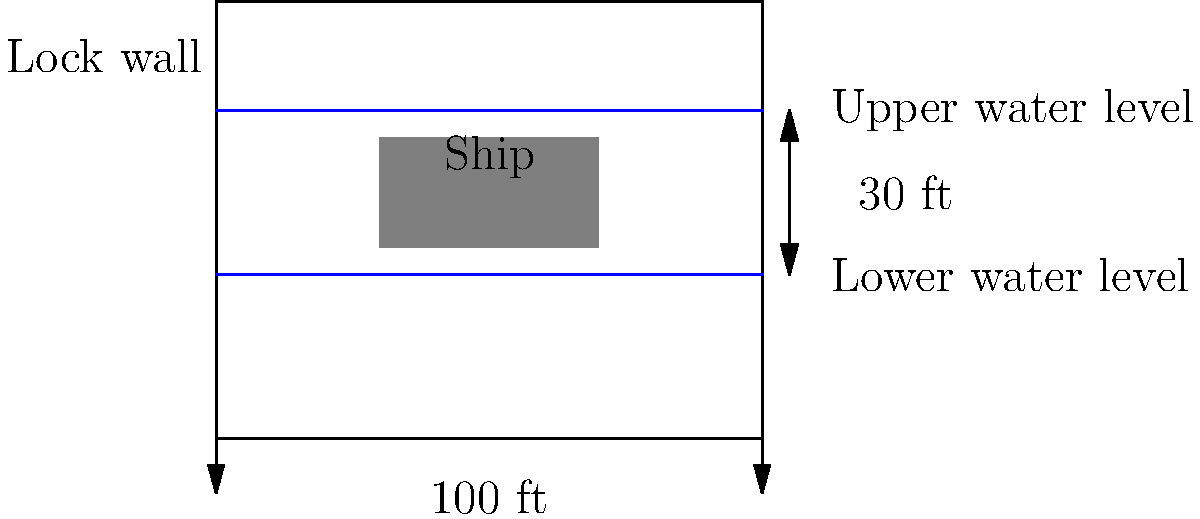In the cross-sectional design of the Panama Canal locks, what is the typical difference in water levels between the upper and lower chambers, and how does this affect the positioning of ships during the lock operation? To answer this question, let's analyze the cross-sectional design of the Panama Canal locks step by step:

1. Water levels:
   - The diagram shows two distinct water levels within the lock.
   - The lower water level represents the entrance or exit of the lock.
   - The upper water level represents the raised water level inside the lock.

2. Vertical distance:
   - The difference between the upper and lower water levels is labeled as 30 ft.
   - This 30 ft difference is the typical height that ships need to be raised or lowered in each lock chamber.

3. Lock dimensions:
   - The width of the lock is shown as 100 ft, which is close to the actual width of the original Panama Canal locks (110 ft).

4. Ship positioning:
   - The ship is shown positioned between the two water levels.
   - This indicates that the ship enters at the lower water level and is then raised to the upper water level.

5. Lock operation:
   - When a ship enters the lock, the lower gates are closed, and water is pumped into the chamber.
   - As the water level rises, the ship is lifted to the height of the upper water level.
   - Once the water levels are equal, the upper gates can be opened, allowing the ship to proceed.

6. Impact on ship design:
   - Ships must be designed to fit within the lock dimensions and account for the water level changes.
   - The maximum ship dimensions are determined by the lock size and the water level difference.

7. Historical context:
   - This lock design was revolutionary when the Panama Canal was built, allowing ships to "climb" the continental divide.
   - The system of locks eliminated the need for a sea-level canal, which would have been much more challenging to construct.

The 30 ft difference in water levels is crucial for the efficient operation of the canal, allowing ships to be raised or lowered in stages as they pass through the isthmus of Panama.
Answer: 30 ft difference; ships positioned between levels and raised/lowered accordingly 